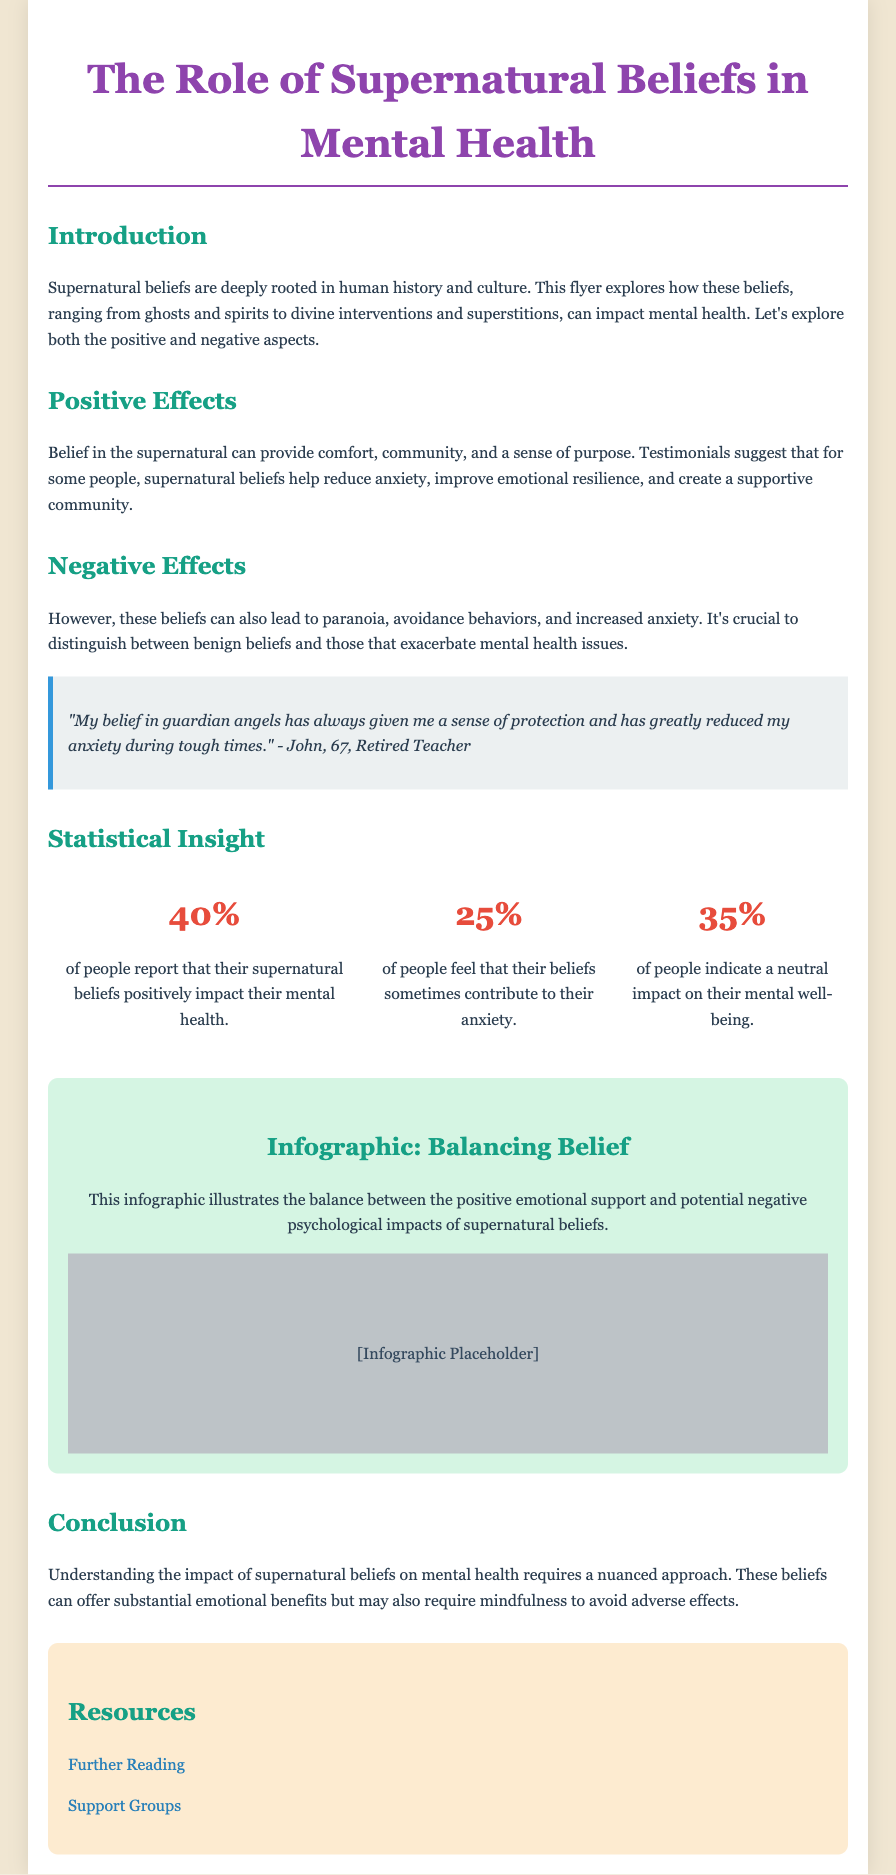What is the title of the flyer? The title of the flyer is prominently displayed at the top of the document.
Answer: The Role of Supernatural Beliefs in Mental Health What percentage of people report that their supernatural beliefs positively impact their mental health? This statistic is presented in the statistical insight section of the flyer.
Answer: 40% Who provided a testimonial about the effects of supernatural beliefs? This information is found in the section containing testimonials from individuals.
Answer: John What is the color used for the heading in the "Positive Effects" section? The color of the headings is indicated through the document's styling.
Answer: Teal What percentage of people feel that their beliefs sometimes contribute to their anxiety? This percentage is also shared in the statistical insight section.
Answer: 25% What is the background color of the infographic section? The background color is mentioned in the description of the section's style.
Answer: Light green What does the infographic illustrate? The document mentions the focus of the infographic in its description.
Answer: The balance between the positive emotional support and potential negative psychological impacts of supernatural beliefs What should readers practice to avoid adverse effects of supernatural beliefs? This suggestion is found in the conclusion of the flyer.
Answer: Mindfulness 